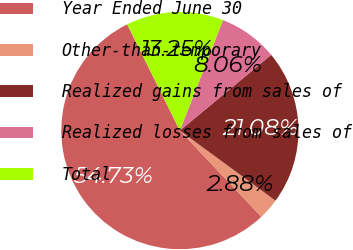Convert chart. <chart><loc_0><loc_0><loc_500><loc_500><pie_chart><fcel>Year Ended June 30<fcel>Other-than-temporary<fcel>Realized gains from sales of<fcel>Realized losses from sales of<fcel>Total<nl><fcel>54.72%<fcel>2.88%<fcel>21.08%<fcel>8.06%<fcel>13.25%<nl></chart> 